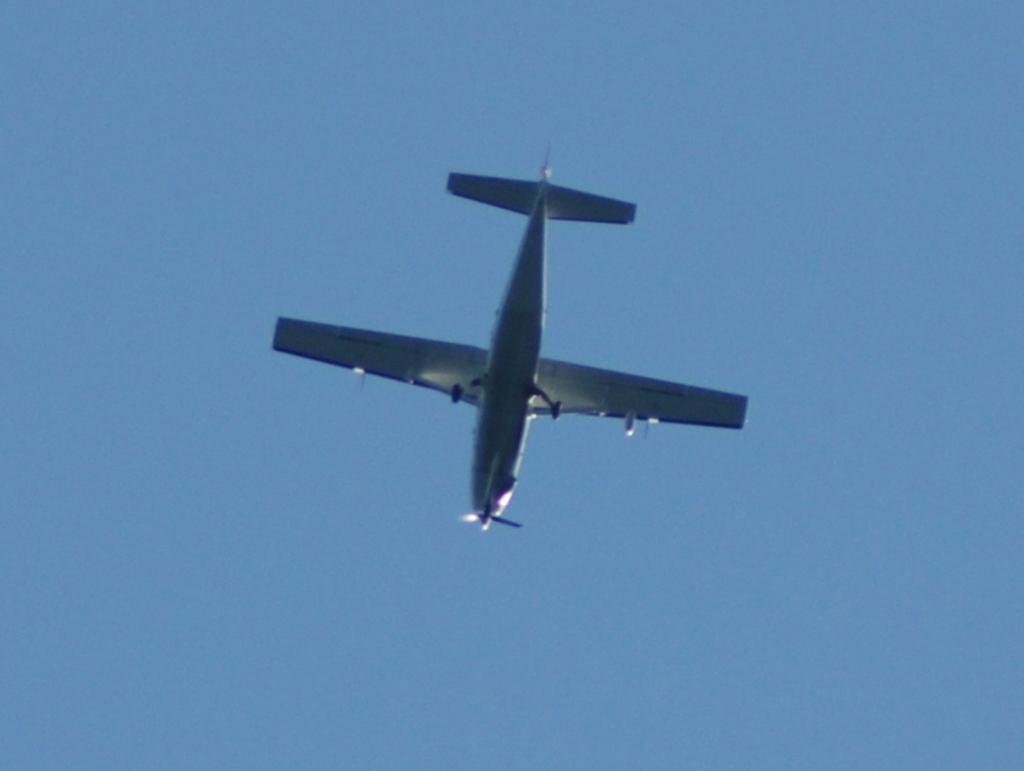What is the color of the sky in the image? The sky is blue in the image. What can be seen flying in the sky in the image? There is an aeroplane in the image. What is the color of the aeroplane? The aeroplane is white in color. What is the aeroplane doing in the image? The aeroplane is flying in the sky. Can you see any blood on the aeroplane in the image? There is no blood present on the aeroplane in the image. Is there a glove being used by the aeroplane in the image? There is no glove present in the image, and aeroplanes do not use gloves. 